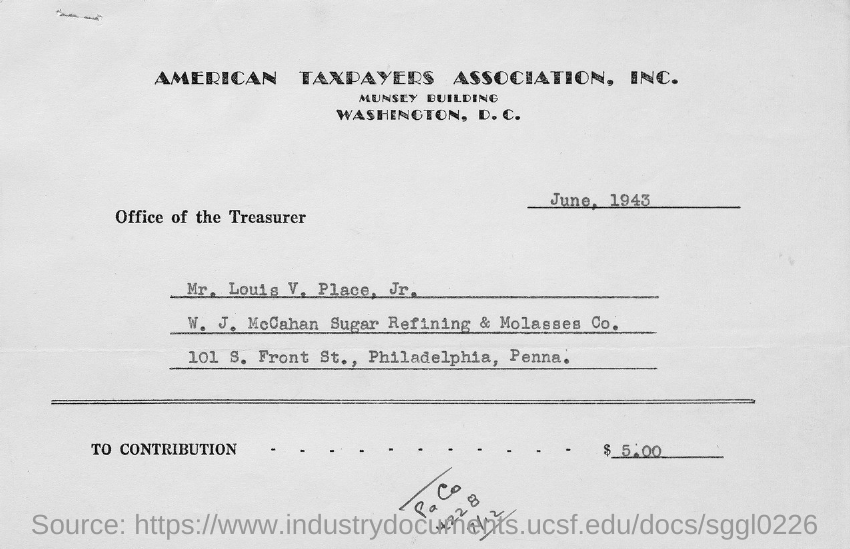Identify some key points in this picture. The document indicates that it was created on June, 1943. 